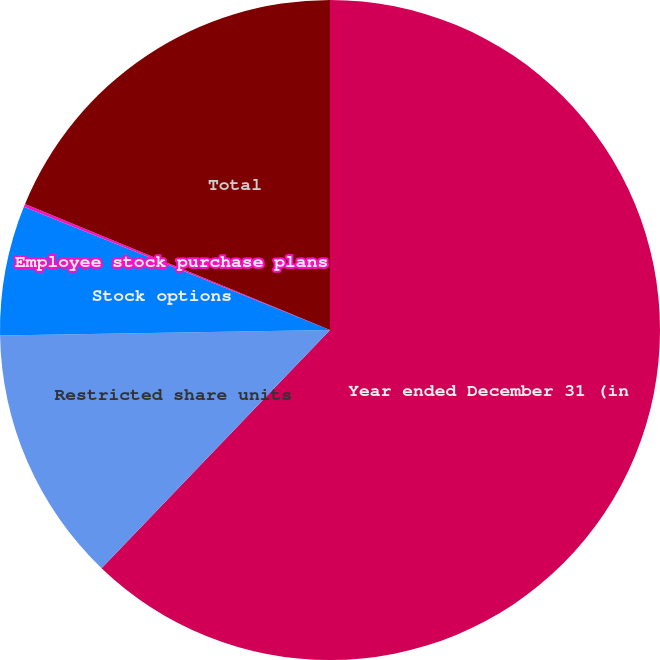<chart> <loc_0><loc_0><loc_500><loc_500><pie_chart><fcel>Year ended December 31 (in<fcel>Restricted share units<fcel>Stock options<fcel>Employee stock purchase plans<fcel>Total<nl><fcel>62.17%<fcel>12.56%<fcel>6.36%<fcel>0.15%<fcel>18.76%<nl></chart> 